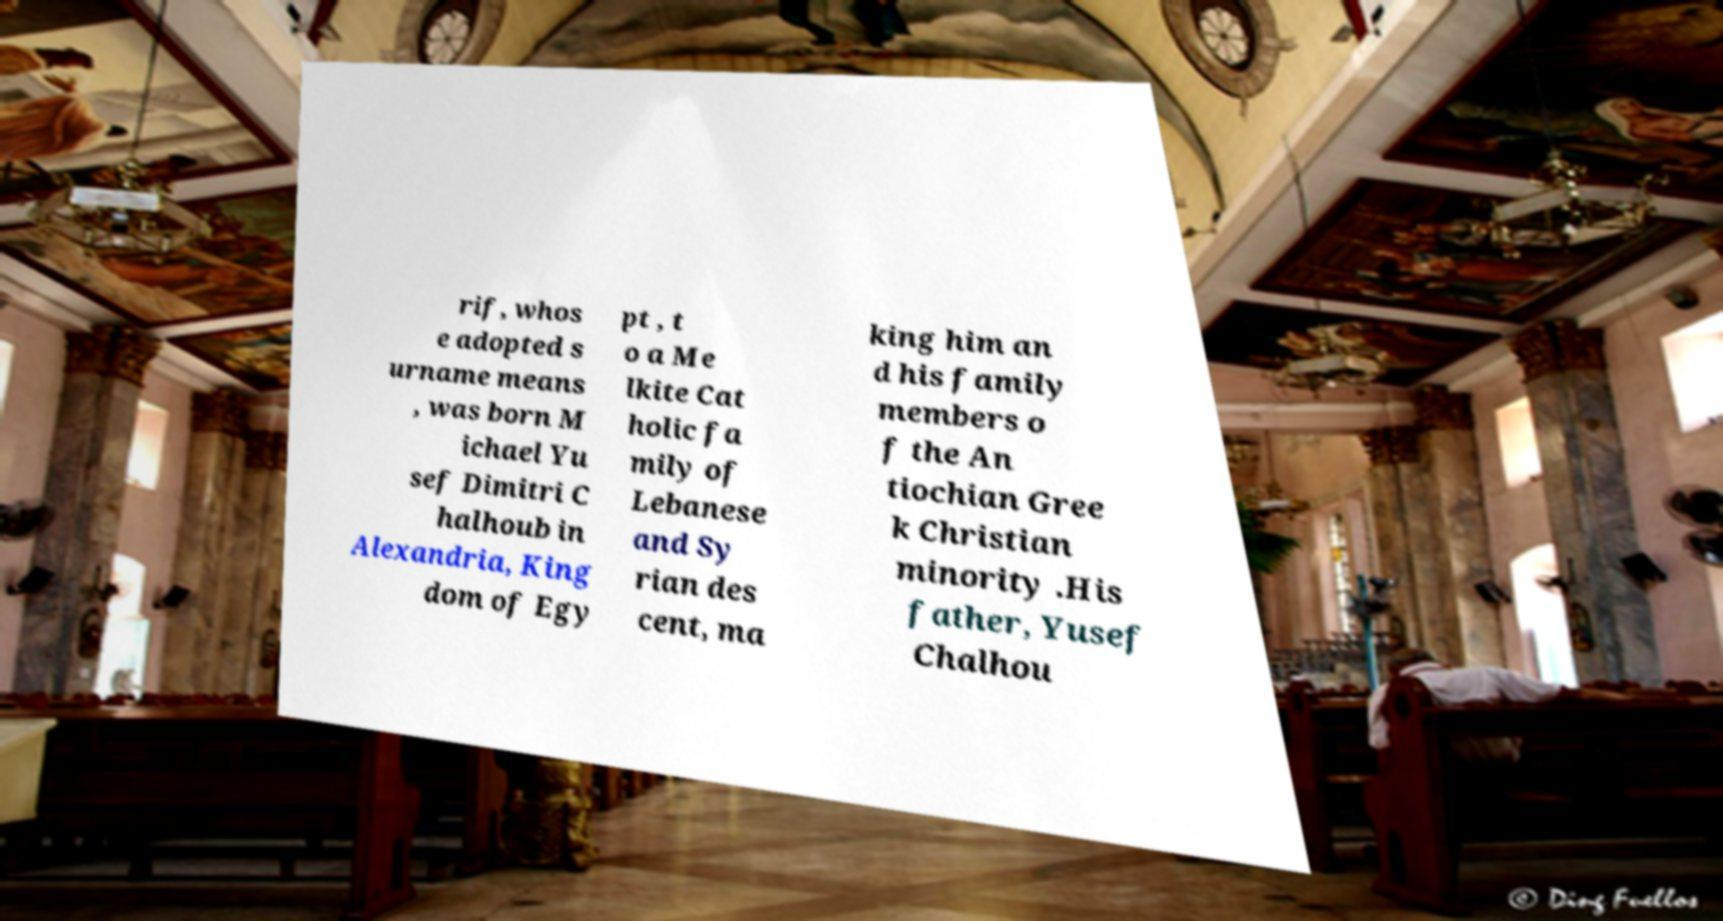Can you accurately transcribe the text from the provided image for me? rif, whos e adopted s urname means , was born M ichael Yu sef Dimitri C halhoub in Alexandria, King dom of Egy pt , t o a Me lkite Cat holic fa mily of Lebanese and Sy rian des cent, ma king him an d his family members o f the An tiochian Gree k Christian minority .His father, Yusef Chalhou 